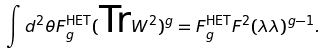Convert formula to latex. <formula><loc_0><loc_0><loc_500><loc_500>\int d ^ { 2 } \theta F _ { g } ^ { \text {HET} } ( \text {Tr} W ^ { 2 } ) ^ { g } = F _ { g } ^ { \text {HET} } F ^ { 2 } ( \lambda \lambda ) ^ { g - 1 } .</formula> 